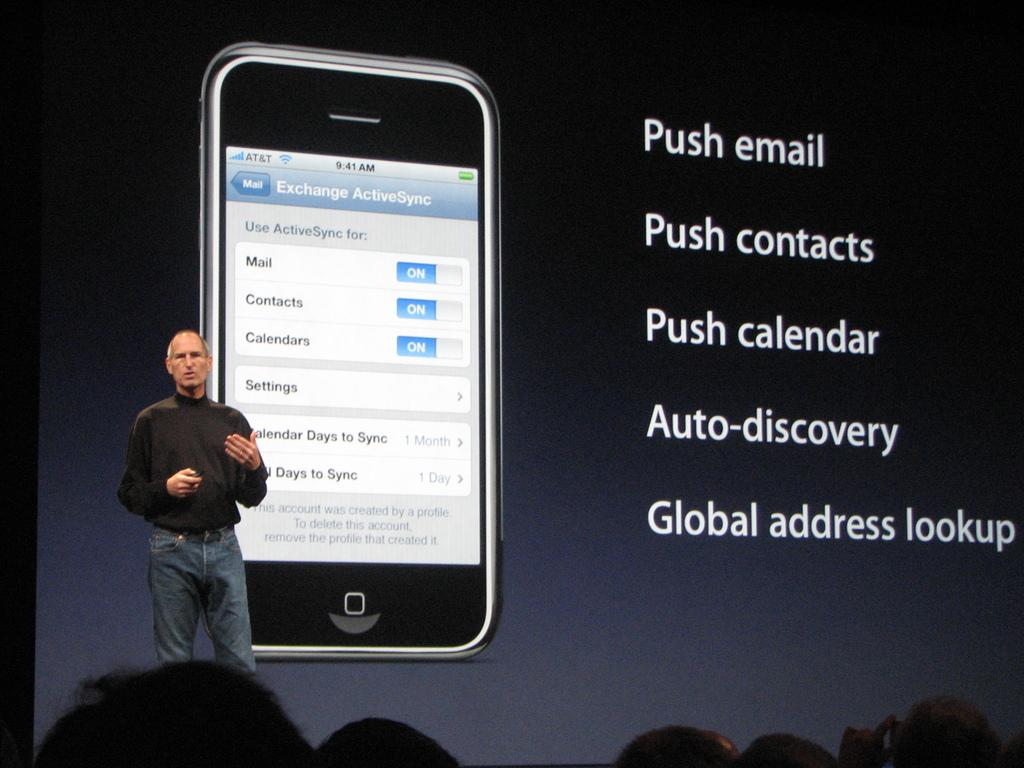<image>
Relay a brief, clear account of the picture shown. a man standing next to some words that say push email and push contacts 